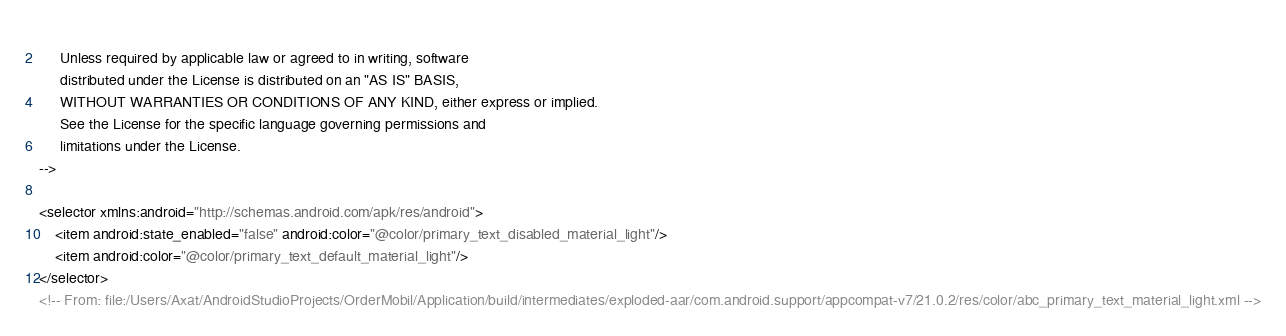Convert code to text. <code><loc_0><loc_0><loc_500><loc_500><_XML_>  
     Unless required by applicable law or agreed to in writing, software
     distributed under the License is distributed on an "AS IS" BASIS,
     WITHOUT WARRANTIES OR CONDITIONS OF ANY KIND, either express or implied.
     See the License for the specific language governing permissions and
     limitations under the License.
-->

<selector xmlns:android="http://schemas.android.com/apk/res/android">
    <item android:state_enabled="false" android:color="@color/primary_text_disabled_material_light"/>
    <item android:color="@color/primary_text_default_material_light"/>
</selector>
<!-- From: file:/Users/Axat/AndroidStudioProjects/OrderMobil/Application/build/intermediates/exploded-aar/com.android.support/appcompat-v7/21.0.2/res/color/abc_primary_text_material_light.xml --></code> 